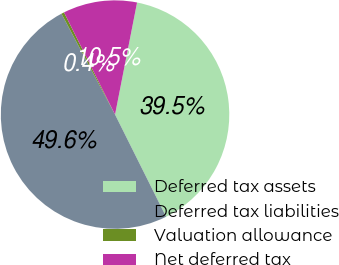<chart> <loc_0><loc_0><loc_500><loc_500><pie_chart><fcel>Deferred tax assets<fcel>Deferred tax liabilities<fcel>Valuation allowance<fcel>Net deferred tax<nl><fcel>39.54%<fcel>49.6%<fcel>0.4%<fcel>10.46%<nl></chart> 